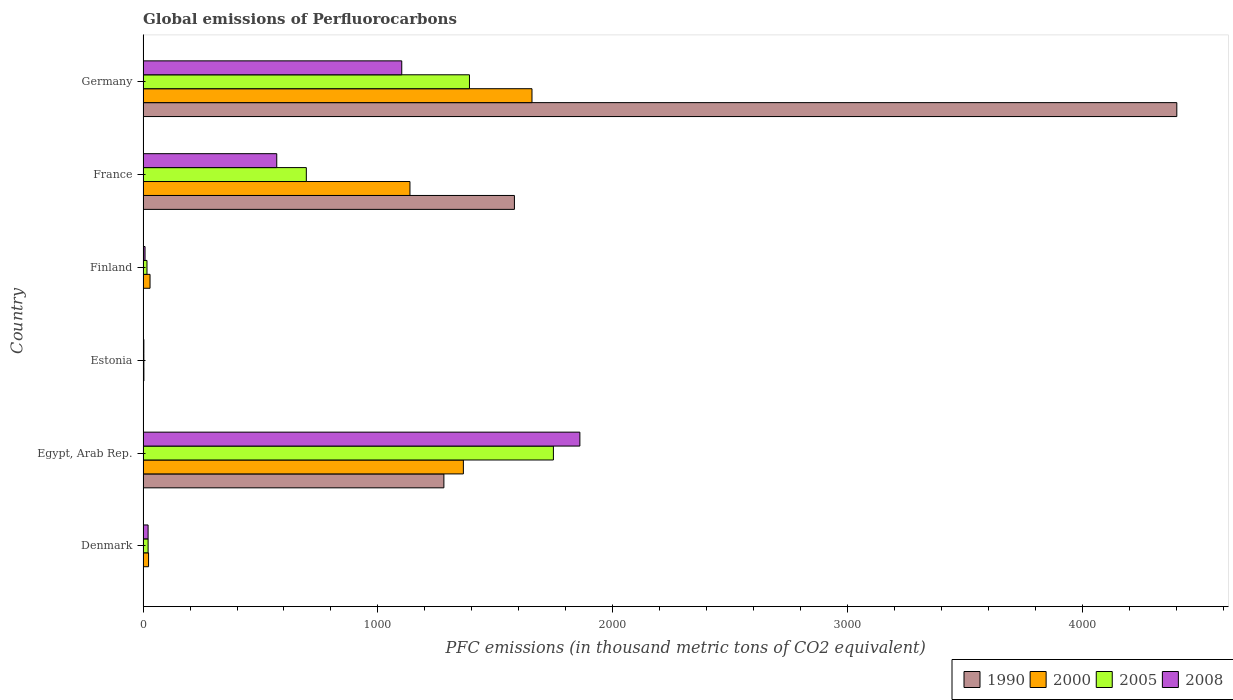Are the number of bars per tick equal to the number of legend labels?
Offer a very short reply. Yes. Are the number of bars on each tick of the Y-axis equal?
Offer a very short reply. Yes. How many bars are there on the 5th tick from the top?
Provide a short and direct response. 4. What is the label of the 4th group of bars from the top?
Your answer should be compact. Estonia. What is the global emissions of Perfluorocarbons in 2000 in Denmark?
Your answer should be compact. 23.4. Across all countries, what is the maximum global emissions of Perfluorocarbons in 1990?
Keep it short and to the point. 4401.3. In which country was the global emissions of Perfluorocarbons in 2000 maximum?
Your answer should be compact. Germany. In which country was the global emissions of Perfluorocarbons in 2008 minimum?
Keep it short and to the point. Estonia. What is the total global emissions of Perfluorocarbons in 2005 in the graph?
Your answer should be compact. 3873.5. What is the difference between the global emissions of Perfluorocarbons in 2005 in Finland and that in Germany?
Provide a succinct answer. -1373. What is the difference between the global emissions of Perfluorocarbons in 2000 in Egypt, Arab Rep. and the global emissions of Perfluorocarbons in 2005 in Germany?
Your response must be concise. -25.9. What is the average global emissions of Perfluorocarbons in 2008 per country?
Ensure brevity in your answer.  593.93. What is the difference between the global emissions of Perfluorocarbons in 2008 and global emissions of Perfluorocarbons in 2005 in Egypt, Arab Rep.?
Your answer should be compact. 112.7. In how many countries, is the global emissions of Perfluorocarbons in 1990 greater than 1000 thousand metric tons?
Make the answer very short. 3. What is the difference between the highest and the second highest global emissions of Perfluorocarbons in 2005?
Give a very brief answer. 357.4. What is the difference between the highest and the lowest global emissions of Perfluorocarbons in 2008?
Give a very brief answer. 1856.4. In how many countries, is the global emissions of Perfluorocarbons in 2008 greater than the average global emissions of Perfluorocarbons in 2008 taken over all countries?
Offer a terse response. 2. Is the sum of the global emissions of Perfluorocarbons in 2008 in Finland and France greater than the maximum global emissions of Perfluorocarbons in 1990 across all countries?
Provide a short and direct response. No. Is it the case that in every country, the sum of the global emissions of Perfluorocarbons in 2008 and global emissions of Perfluorocarbons in 2005 is greater than the sum of global emissions of Perfluorocarbons in 2000 and global emissions of Perfluorocarbons in 1990?
Your answer should be very brief. No. Is it the case that in every country, the sum of the global emissions of Perfluorocarbons in 2008 and global emissions of Perfluorocarbons in 2005 is greater than the global emissions of Perfluorocarbons in 2000?
Your response must be concise. No. Are all the bars in the graph horizontal?
Ensure brevity in your answer.  Yes. How many legend labels are there?
Offer a terse response. 4. How are the legend labels stacked?
Ensure brevity in your answer.  Horizontal. What is the title of the graph?
Your answer should be very brief. Global emissions of Perfluorocarbons. Does "2003" appear as one of the legend labels in the graph?
Make the answer very short. No. What is the label or title of the X-axis?
Your answer should be very brief. PFC emissions (in thousand metric tons of CO2 equivalent). What is the label or title of the Y-axis?
Offer a very short reply. Country. What is the PFC emissions (in thousand metric tons of CO2 equivalent) of 1990 in Denmark?
Your answer should be very brief. 1.4. What is the PFC emissions (in thousand metric tons of CO2 equivalent) in 2000 in Denmark?
Your answer should be very brief. 23.4. What is the PFC emissions (in thousand metric tons of CO2 equivalent) in 2008 in Denmark?
Your answer should be compact. 21.4. What is the PFC emissions (in thousand metric tons of CO2 equivalent) in 1990 in Egypt, Arab Rep.?
Ensure brevity in your answer.  1280.8. What is the PFC emissions (in thousand metric tons of CO2 equivalent) of 2000 in Egypt, Arab Rep.?
Provide a succinct answer. 1363.8. What is the PFC emissions (in thousand metric tons of CO2 equivalent) in 2005 in Egypt, Arab Rep.?
Make the answer very short. 1747.1. What is the PFC emissions (in thousand metric tons of CO2 equivalent) in 2008 in Egypt, Arab Rep.?
Offer a terse response. 1859.8. What is the PFC emissions (in thousand metric tons of CO2 equivalent) of 2000 in Estonia?
Keep it short and to the point. 3.5. What is the PFC emissions (in thousand metric tons of CO2 equivalent) of 2005 in Estonia?
Your response must be concise. 3.4. What is the PFC emissions (in thousand metric tons of CO2 equivalent) of 2008 in Estonia?
Ensure brevity in your answer.  3.4. What is the PFC emissions (in thousand metric tons of CO2 equivalent) of 1990 in Finland?
Your response must be concise. 1.7. What is the PFC emissions (in thousand metric tons of CO2 equivalent) of 2000 in Finland?
Your answer should be compact. 29.7. What is the PFC emissions (in thousand metric tons of CO2 equivalent) in 2008 in Finland?
Ensure brevity in your answer.  8.4. What is the PFC emissions (in thousand metric tons of CO2 equivalent) of 1990 in France?
Provide a short and direct response. 1581.1. What is the PFC emissions (in thousand metric tons of CO2 equivalent) of 2000 in France?
Give a very brief answer. 1136.3. What is the PFC emissions (in thousand metric tons of CO2 equivalent) of 2005 in France?
Offer a terse response. 695.1. What is the PFC emissions (in thousand metric tons of CO2 equivalent) in 2008 in France?
Keep it short and to the point. 569.2. What is the PFC emissions (in thousand metric tons of CO2 equivalent) in 1990 in Germany?
Keep it short and to the point. 4401.3. What is the PFC emissions (in thousand metric tons of CO2 equivalent) of 2000 in Germany?
Give a very brief answer. 1655.9. What is the PFC emissions (in thousand metric tons of CO2 equivalent) of 2005 in Germany?
Give a very brief answer. 1389.7. What is the PFC emissions (in thousand metric tons of CO2 equivalent) in 2008 in Germany?
Keep it short and to the point. 1101.4. Across all countries, what is the maximum PFC emissions (in thousand metric tons of CO2 equivalent) of 1990?
Keep it short and to the point. 4401.3. Across all countries, what is the maximum PFC emissions (in thousand metric tons of CO2 equivalent) of 2000?
Offer a terse response. 1655.9. Across all countries, what is the maximum PFC emissions (in thousand metric tons of CO2 equivalent) of 2005?
Your answer should be very brief. 1747.1. Across all countries, what is the maximum PFC emissions (in thousand metric tons of CO2 equivalent) in 2008?
Make the answer very short. 1859.8. Across all countries, what is the minimum PFC emissions (in thousand metric tons of CO2 equivalent) of 1990?
Your answer should be compact. 0.5. Across all countries, what is the minimum PFC emissions (in thousand metric tons of CO2 equivalent) of 2000?
Keep it short and to the point. 3.5. Across all countries, what is the minimum PFC emissions (in thousand metric tons of CO2 equivalent) of 2005?
Your response must be concise. 3.4. Across all countries, what is the minimum PFC emissions (in thousand metric tons of CO2 equivalent) in 2008?
Offer a very short reply. 3.4. What is the total PFC emissions (in thousand metric tons of CO2 equivalent) of 1990 in the graph?
Make the answer very short. 7266.8. What is the total PFC emissions (in thousand metric tons of CO2 equivalent) in 2000 in the graph?
Ensure brevity in your answer.  4212.6. What is the total PFC emissions (in thousand metric tons of CO2 equivalent) of 2005 in the graph?
Offer a terse response. 3873.5. What is the total PFC emissions (in thousand metric tons of CO2 equivalent) of 2008 in the graph?
Offer a terse response. 3563.6. What is the difference between the PFC emissions (in thousand metric tons of CO2 equivalent) of 1990 in Denmark and that in Egypt, Arab Rep.?
Give a very brief answer. -1279.4. What is the difference between the PFC emissions (in thousand metric tons of CO2 equivalent) of 2000 in Denmark and that in Egypt, Arab Rep.?
Your answer should be compact. -1340.4. What is the difference between the PFC emissions (in thousand metric tons of CO2 equivalent) in 2005 in Denmark and that in Egypt, Arab Rep.?
Give a very brief answer. -1725.6. What is the difference between the PFC emissions (in thousand metric tons of CO2 equivalent) of 2008 in Denmark and that in Egypt, Arab Rep.?
Make the answer very short. -1838.4. What is the difference between the PFC emissions (in thousand metric tons of CO2 equivalent) in 1990 in Denmark and that in Estonia?
Keep it short and to the point. 0.9. What is the difference between the PFC emissions (in thousand metric tons of CO2 equivalent) in 2005 in Denmark and that in Estonia?
Offer a very short reply. 18.1. What is the difference between the PFC emissions (in thousand metric tons of CO2 equivalent) in 1990 in Denmark and that in Finland?
Your answer should be very brief. -0.3. What is the difference between the PFC emissions (in thousand metric tons of CO2 equivalent) of 2005 in Denmark and that in Finland?
Ensure brevity in your answer.  4.8. What is the difference between the PFC emissions (in thousand metric tons of CO2 equivalent) of 2008 in Denmark and that in Finland?
Give a very brief answer. 13. What is the difference between the PFC emissions (in thousand metric tons of CO2 equivalent) of 1990 in Denmark and that in France?
Keep it short and to the point. -1579.7. What is the difference between the PFC emissions (in thousand metric tons of CO2 equivalent) of 2000 in Denmark and that in France?
Provide a short and direct response. -1112.9. What is the difference between the PFC emissions (in thousand metric tons of CO2 equivalent) in 2005 in Denmark and that in France?
Your answer should be compact. -673.6. What is the difference between the PFC emissions (in thousand metric tons of CO2 equivalent) in 2008 in Denmark and that in France?
Your answer should be compact. -547.8. What is the difference between the PFC emissions (in thousand metric tons of CO2 equivalent) in 1990 in Denmark and that in Germany?
Ensure brevity in your answer.  -4399.9. What is the difference between the PFC emissions (in thousand metric tons of CO2 equivalent) in 2000 in Denmark and that in Germany?
Make the answer very short. -1632.5. What is the difference between the PFC emissions (in thousand metric tons of CO2 equivalent) of 2005 in Denmark and that in Germany?
Your response must be concise. -1368.2. What is the difference between the PFC emissions (in thousand metric tons of CO2 equivalent) in 2008 in Denmark and that in Germany?
Ensure brevity in your answer.  -1080. What is the difference between the PFC emissions (in thousand metric tons of CO2 equivalent) of 1990 in Egypt, Arab Rep. and that in Estonia?
Your response must be concise. 1280.3. What is the difference between the PFC emissions (in thousand metric tons of CO2 equivalent) in 2000 in Egypt, Arab Rep. and that in Estonia?
Offer a terse response. 1360.3. What is the difference between the PFC emissions (in thousand metric tons of CO2 equivalent) in 2005 in Egypt, Arab Rep. and that in Estonia?
Your answer should be compact. 1743.7. What is the difference between the PFC emissions (in thousand metric tons of CO2 equivalent) of 2008 in Egypt, Arab Rep. and that in Estonia?
Provide a succinct answer. 1856.4. What is the difference between the PFC emissions (in thousand metric tons of CO2 equivalent) of 1990 in Egypt, Arab Rep. and that in Finland?
Make the answer very short. 1279.1. What is the difference between the PFC emissions (in thousand metric tons of CO2 equivalent) of 2000 in Egypt, Arab Rep. and that in Finland?
Give a very brief answer. 1334.1. What is the difference between the PFC emissions (in thousand metric tons of CO2 equivalent) of 2005 in Egypt, Arab Rep. and that in Finland?
Your answer should be very brief. 1730.4. What is the difference between the PFC emissions (in thousand metric tons of CO2 equivalent) in 2008 in Egypt, Arab Rep. and that in Finland?
Make the answer very short. 1851.4. What is the difference between the PFC emissions (in thousand metric tons of CO2 equivalent) in 1990 in Egypt, Arab Rep. and that in France?
Give a very brief answer. -300.3. What is the difference between the PFC emissions (in thousand metric tons of CO2 equivalent) of 2000 in Egypt, Arab Rep. and that in France?
Provide a succinct answer. 227.5. What is the difference between the PFC emissions (in thousand metric tons of CO2 equivalent) in 2005 in Egypt, Arab Rep. and that in France?
Your answer should be compact. 1052. What is the difference between the PFC emissions (in thousand metric tons of CO2 equivalent) in 2008 in Egypt, Arab Rep. and that in France?
Keep it short and to the point. 1290.6. What is the difference between the PFC emissions (in thousand metric tons of CO2 equivalent) in 1990 in Egypt, Arab Rep. and that in Germany?
Offer a terse response. -3120.5. What is the difference between the PFC emissions (in thousand metric tons of CO2 equivalent) of 2000 in Egypt, Arab Rep. and that in Germany?
Ensure brevity in your answer.  -292.1. What is the difference between the PFC emissions (in thousand metric tons of CO2 equivalent) of 2005 in Egypt, Arab Rep. and that in Germany?
Provide a succinct answer. 357.4. What is the difference between the PFC emissions (in thousand metric tons of CO2 equivalent) of 2008 in Egypt, Arab Rep. and that in Germany?
Your response must be concise. 758.4. What is the difference between the PFC emissions (in thousand metric tons of CO2 equivalent) of 2000 in Estonia and that in Finland?
Ensure brevity in your answer.  -26.2. What is the difference between the PFC emissions (in thousand metric tons of CO2 equivalent) in 2005 in Estonia and that in Finland?
Give a very brief answer. -13.3. What is the difference between the PFC emissions (in thousand metric tons of CO2 equivalent) of 2008 in Estonia and that in Finland?
Offer a terse response. -5. What is the difference between the PFC emissions (in thousand metric tons of CO2 equivalent) in 1990 in Estonia and that in France?
Give a very brief answer. -1580.6. What is the difference between the PFC emissions (in thousand metric tons of CO2 equivalent) in 2000 in Estonia and that in France?
Keep it short and to the point. -1132.8. What is the difference between the PFC emissions (in thousand metric tons of CO2 equivalent) in 2005 in Estonia and that in France?
Make the answer very short. -691.7. What is the difference between the PFC emissions (in thousand metric tons of CO2 equivalent) in 2008 in Estonia and that in France?
Your answer should be very brief. -565.8. What is the difference between the PFC emissions (in thousand metric tons of CO2 equivalent) of 1990 in Estonia and that in Germany?
Your answer should be very brief. -4400.8. What is the difference between the PFC emissions (in thousand metric tons of CO2 equivalent) of 2000 in Estonia and that in Germany?
Give a very brief answer. -1652.4. What is the difference between the PFC emissions (in thousand metric tons of CO2 equivalent) of 2005 in Estonia and that in Germany?
Offer a very short reply. -1386.3. What is the difference between the PFC emissions (in thousand metric tons of CO2 equivalent) in 2008 in Estonia and that in Germany?
Provide a short and direct response. -1098. What is the difference between the PFC emissions (in thousand metric tons of CO2 equivalent) of 1990 in Finland and that in France?
Provide a succinct answer. -1579.4. What is the difference between the PFC emissions (in thousand metric tons of CO2 equivalent) in 2000 in Finland and that in France?
Keep it short and to the point. -1106.6. What is the difference between the PFC emissions (in thousand metric tons of CO2 equivalent) of 2005 in Finland and that in France?
Keep it short and to the point. -678.4. What is the difference between the PFC emissions (in thousand metric tons of CO2 equivalent) of 2008 in Finland and that in France?
Keep it short and to the point. -560.8. What is the difference between the PFC emissions (in thousand metric tons of CO2 equivalent) in 1990 in Finland and that in Germany?
Offer a terse response. -4399.6. What is the difference between the PFC emissions (in thousand metric tons of CO2 equivalent) of 2000 in Finland and that in Germany?
Give a very brief answer. -1626.2. What is the difference between the PFC emissions (in thousand metric tons of CO2 equivalent) of 2005 in Finland and that in Germany?
Keep it short and to the point. -1373. What is the difference between the PFC emissions (in thousand metric tons of CO2 equivalent) of 2008 in Finland and that in Germany?
Keep it short and to the point. -1093. What is the difference between the PFC emissions (in thousand metric tons of CO2 equivalent) in 1990 in France and that in Germany?
Your answer should be very brief. -2820.2. What is the difference between the PFC emissions (in thousand metric tons of CO2 equivalent) of 2000 in France and that in Germany?
Your answer should be compact. -519.6. What is the difference between the PFC emissions (in thousand metric tons of CO2 equivalent) in 2005 in France and that in Germany?
Provide a succinct answer. -694.6. What is the difference between the PFC emissions (in thousand metric tons of CO2 equivalent) in 2008 in France and that in Germany?
Offer a terse response. -532.2. What is the difference between the PFC emissions (in thousand metric tons of CO2 equivalent) of 1990 in Denmark and the PFC emissions (in thousand metric tons of CO2 equivalent) of 2000 in Egypt, Arab Rep.?
Offer a terse response. -1362.4. What is the difference between the PFC emissions (in thousand metric tons of CO2 equivalent) in 1990 in Denmark and the PFC emissions (in thousand metric tons of CO2 equivalent) in 2005 in Egypt, Arab Rep.?
Make the answer very short. -1745.7. What is the difference between the PFC emissions (in thousand metric tons of CO2 equivalent) in 1990 in Denmark and the PFC emissions (in thousand metric tons of CO2 equivalent) in 2008 in Egypt, Arab Rep.?
Make the answer very short. -1858.4. What is the difference between the PFC emissions (in thousand metric tons of CO2 equivalent) of 2000 in Denmark and the PFC emissions (in thousand metric tons of CO2 equivalent) of 2005 in Egypt, Arab Rep.?
Ensure brevity in your answer.  -1723.7. What is the difference between the PFC emissions (in thousand metric tons of CO2 equivalent) in 2000 in Denmark and the PFC emissions (in thousand metric tons of CO2 equivalent) in 2008 in Egypt, Arab Rep.?
Provide a short and direct response. -1836.4. What is the difference between the PFC emissions (in thousand metric tons of CO2 equivalent) in 2005 in Denmark and the PFC emissions (in thousand metric tons of CO2 equivalent) in 2008 in Egypt, Arab Rep.?
Your answer should be compact. -1838.3. What is the difference between the PFC emissions (in thousand metric tons of CO2 equivalent) in 2000 in Denmark and the PFC emissions (in thousand metric tons of CO2 equivalent) in 2005 in Estonia?
Offer a terse response. 20. What is the difference between the PFC emissions (in thousand metric tons of CO2 equivalent) in 1990 in Denmark and the PFC emissions (in thousand metric tons of CO2 equivalent) in 2000 in Finland?
Offer a terse response. -28.3. What is the difference between the PFC emissions (in thousand metric tons of CO2 equivalent) of 1990 in Denmark and the PFC emissions (in thousand metric tons of CO2 equivalent) of 2005 in Finland?
Provide a succinct answer. -15.3. What is the difference between the PFC emissions (in thousand metric tons of CO2 equivalent) in 2000 in Denmark and the PFC emissions (in thousand metric tons of CO2 equivalent) in 2005 in Finland?
Ensure brevity in your answer.  6.7. What is the difference between the PFC emissions (in thousand metric tons of CO2 equivalent) of 1990 in Denmark and the PFC emissions (in thousand metric tons of CO2 equivalent) of 2000 in France?
Provide a succinct answer. -1134.9. What is the difference between the PFC emissions (in thousand metric tons of CO2 equivalent) of 1990 in Denmark and the PFC emissions (in thousand metric tons of CO2 equivalent) of 2005 in France?
Your answer should be compact. -693.7. What is the difference between the PFC emissions (in thousand metric tons of CO2 equivalent) of 1990 in Denmark and the PFC emissions (in thousand metric tons of CO2 equivalent) of 2008 in France?
Your answer should be very brief. -567.8. What is the difference between the PFC emissions (in thousand metric tons of CO2 equivalent) in 2000 in Denmark and the PFC emissions (in thousand metric tons of CO2 equivalent) in 2005 in France?
Keep it short and to the point. -671.7. What is the difference between the PFC emissions (in thousand metric tons of CO2 equivalent) in 2000 in Denmark and the PFC emissions (in thousand metric tons of CO2 equivalent) in 2008 in France?
Keep it short and to the point. -545.8. What is the difference between the PFC emissions (in thousand metric tons of CO2 equivalent) in 2005 in Denmark and the PFC emissions (in thousand metric tons of CO2 equivalent) in 2008 in France?
Your response must be concise. -547.7. What is the difference between the PFC emissions (in thousand metric tons of CO2 equivalent) of 1990 in Denmark and the PFC emissions (in thousand metric tons of CO2 equivalent) of 2000 in Germany?
Your response must be concise. -1654.5. What is the difference between the PFC emissions (in thousand metric tons of CO2 equivalent) of 1990 in Denmark and the PFC emissions (in thousand metric tons of CO2 equivalent) of 2005 in Germany?
Keep it short and to the point. -1388.3. What is the difference between the PFC emissions (in thousand metric tons of CO2 equivalent) of 1990 in Denmark and the PFC emissions (in thousand metric tons of CO2 equivalent) of 2008 in Germany?
Ensure brevity in your answer.  -1100. What is the difference between the PFC emissions (in thousand metric tons of CO2 equivalent) in 2000 in Denmark and the PFC emissions (in thousand metric tons of CO2 equivalent) in 2005 in Germany?
Offer a very short reply. -1366.3. What is the difference between the PFC emissions (in thousand metric tons of CO2 equivalent) of 2000 in Denmark and the PFC emissions (in thousand metric tons of CO2 equivalent) of 2008 in Germany?
Provide a succinct answer. -1078. What is the difference between the PFC emissions (in thousand metric tons of CO2 equivalent) in 2005 in Denmark and the PFC emissions (in thousand metric tons of CO2 equivalent) in 2008 in Germany?
Your response must be concise. -1079.9. What is the difference between the PFC emissions (in thousand metric tons of CO2 equivalent) in 1990 in Egypt, Arab Rep. and the PFC emissions (in thousand metric tons of CO2 equivalent) in 2000 in Estonia?
Your response must be concise. 1277.3. What is the difference between the PFC emissions (in thousand metric tons of CO2 equivalent) of 1990 in Egypt, Arab Rep. and the PFC emissions (in thousand metric tons of CO2 equivalent) of 2005 in Estonia?
Make the answer very short. 1277.4. What is the difference between the PFC emissions (in thousand metric tons of CO2 equivalent) of 1990 in Egypt, Arab Rep. and the PFC emissions (in thousand metric tons of CO2 equivalent) of 2008 in Estonia?
Make the answer very short. 1277.4. What is the difference between the PFC emissions (in thousand metric tons of CO2 equivalent) in 2000 in Egypt, Arab Rep. and the PFC emissions (in thousand metric tons of CO2 equivalent) in 2005 in Estonia?
Your response must be concise. 1360.4. What is the difference between the PFC emissions (in thousand metric tons of CO2 equivalent) of 2000 in Egypt, Arab Rep. and the PFC emissions (in thousand metric tons of CO2 equivalent) of 2008 in Estonia?
Your answer should be very brief. 1360.4. What is the difference between the PFC emissions (in thousand metric tons of CO2 equivalent) of 2005 in Egypt, Arab Rep. and the PFC emissions (in thousand metric tons of CO2 equivalent) of 2008 in Estonia?
Keep it short and to the point. 1743.7. What is the difference between the PFC emissions (in thousand metric tons of CO2 equivalent) of 1990 in Egypt, Arab Rep. and the PFC emissions (in thousand metric tons of CO2 equivalent) of 2000 in Finland?
Provide a succinct answer. 1251.1. What is the difference between the PFC emissions (in thousand metric tons of CO2 equivalent) in 1990 in Egypt, Arab Rep. and the PFC emissions (in thousand metric tons of CO2 equivalent) in 2005 in Finland?
Your answer should be very brief. 1264.1. What is the difference between the PFC emissions (in thousand metric tons of CO2 equivalent) in 1990 in Egypt, Arab Rep. and the PFC emissions (in thousand metric tons of CO2 equivalent) in 2008 in Finland?
Give a very brief answer. 1272.4. What is the difference between the PFC emissions (in thousand metric tons of CO2 equivalent) of 2000 in Egypt, Arab Rep. and the PFC emissions (in thousand metric tons of CO2 equivalent) of 2005 in Finland?
Provide a short and direct response. 1347.1. What is the difference between the PFC emissions (in thousand metric tons of CO2 equivalent) in 2000 in Egypt, Arab Rep. and the PFC emissions (in thousand metric tons of CO2 equivalent) in 2008 in Finland?
Ensure brevity in your answer.  1355.4. What is the difference between the PFC emissions (in thousand metric tons of CO2 equivalent) of 2005 in Egypt, Arab Rep. and the PFC emissions (in thousand metric tons of CO2 equivalent) of 2008 in Finland?
Provide a succinct answer. 1738.7. What is the difference between the PFC emissions (in thousand metric tons of CO2 equivalent) in 1990 in Egypt, Arab Rep. and the PFC emissions (in thousand metric tons of CO2 equivalent) in 2000 in France?
Ensure brevity in your answer.  144.5. What is the difference between the PFC emissions (in thousand metric tons of CO2 equivalent) in 1990 in Egypt, Arab Rep. and the PFC emissions (in thousand metric tons of CO2 equivalent) in 2005 in France?
Make the answer very short. 585.7. What is the difference between the PFC emissions (in thousand metric tons of CO2 equivalent) of 1990 in Egypt, Arab Rep. and the PFC emissions (in thousand metric tons of CO2 equivalent) of 2008 in France?
Make the answer very short. 711.6. What is the difference between the PFC emissions (in thousand metric tons of CO2 equivalent) in 2000 in Egypt, Arab Rep. and the PFC emissions (in thousand metric tons of CO2 equivalent) in 2005 in France?
Your answer should be very brief. 668.7. What is the difference between the PFC emissions (in thousand metric tons of CO2 equivalent) of 2000 in Egypt, Arab Rep. and the PFC emissions (in thousand metric tons of CO2 equivalent) of 2008 in France?
Offer a terse response. 794.6. What is the difference between the PFC emissions (in thousand metric tons of CO2 equivalent) of 2005 in Egypt, Arab Rep. and the PFC emissions (in thousand metric tons of CO2 equivalent) of 2008 in France?
Give a very brief answer. 1177.9. What is the difference between the PFC emissions (in thousand metric tons of CO2 equivalent) in 1990 in Egypt, Arab Rep. and the PFC emissions (in thousand metric tons of CO2 equivalent) in 2000 in Germany?
Your answer should be compact. -375.1. What is the difference between the PFC emissions (in thousand metric tons of CO2 equivalent) of 1990 in Egypt, Arab Rep. and the PFC emissions (in thousand metric tons of CO2 equivalent) of 2005 in Germany?
Your answer should be very brief. -108.9. What is the difference between the PFC emissions (in thousand metric tons of CO2 equivalent) of 1990 in Egypt, Arab Rep. and the PFC emissions (in thousand metric tons of CO2 equivalent) of 2008 in Germany?
Your answer should be compact. 179.4. What is the difference between the PFC emissions (in thousand metric tons of CO2 equivalent) of 2000 in Egypt, Arab Rep. and the PFC emissions (in thousand metric tons of CO2 equivalent) of 2005 in Germany?
Your response must be concise. -25.9. What is the difference between the PFC emissions (in thousand metric tons of CO2 equivalent) of 2000 in Egypt, Arab Rep. and the PFC emissions (in thousand metric tons of CO2 equivalent) of 2008 in Germany?
Your answer should be very brief. 262.4. What is the difference between the PFC emissions (in thousand metric tons of CO2 equivalent) of 2005 in Egypt, Arab Rep. and the PFC emissions (in thousand metric tons of CO2 equivalent) of 2008 in Germany?
Keep it short and to the point. 645.7. What is the difference between the PFC emissions (in thousand metric tons of CO2 equivalent) of 1990 in Estonia and the PFC emissions (in thousand metric tons of CO2 equivalent) of 2000 in Finland?
Your answer should be compact. -29.2. What is the difference between the PFC emissions (in thousand metric tons of CO2 equivalent) of 1990 in Estonia and the PFC emissions (in thousand metric tons of CO2 equivalent) of 2005 in Finland?
Make the answer very short. -16.2. What is the difference between the PFC emissions (in thousand metric tons of CO2 equivalent) of 1990 in Estonia and the PFC emissions (in thousand metric tons of CO2 equivalent) of 2000 in France?
Make the answer very short. -1135.8. What is the difference between the PFC emissions (in thousand metric tons of CO2 equivalent) of 1990 in Estonia and the PFC emissions (in thousand metric tons of CO2 equivalent) of 2005 in France?
Give a very brief answer. -694.6. What is the difference between the PFC emissions (in thousand metric tons of CO2 equivalent) in 1990 in Estonia and the PFC emissions (in thousand metric tons of CO2 equivalent) in 2008 in France?
Your response must be concise. -568.7. What is the difference between the PFC emissions (in thousand metric tons of CO2 equivalent) in 2000 in Estonia and the PFC emissions (in thousand metric tons of CO2 equivalent) in 2005 in France?
Your response must be concise. -691.6. What is the difference between the PFC emissions (in thousand metric tons of CO2 equivalent) in 2000 in Estonia and the PFC emissions (in thousand metric tons of CO2 equivalent) in 2008 in France?
Keep it short and to the point. -565.7. What is the difference between the PFC emissions (in thousand metric tons of CO2 equivalent) of 2005 in Estonia and the PFC emissions (in thousand metric tons of CO2 equivalent) of 2008 in France?
Your answer should be compact. -565.8. What is the difference between the PFC emissions (in thousand metric tons of CO2 equivalent) in 1990 in Estonia and the PFC emissions (in thousand metric tons of CO2 equivalent) in 2000 in Germany?
Your answer should be very brief. -1655.4. What is the difference between the PFC emissions (in thousand metric tons of CO2 equivalent) of 1990 in Estonia and the PFC emissions (in thousand metric tons of CO2 equivalent) of 2005 in Germany?
Provide a succinct answer. -1389.2. What is the difference between the PFC emissions (in thousand metric tons of CO2 equivalent) in 1990 in Estonia and the PFC emissions (in thousand metric tons of CO2 equivalent) in 2008 in Germany?
Ensure brevity in your answer.  -1100.9. What is the difference between the PFC emissions (in thousand metric tons of CO2 equivalent) in 2000 in Estonia and the PFC emissions (in thousand metric tons of CO2 equivalent) in 2005 in Germany?
Ensure brevity in your answer.  -1386.2. What is the difference between the PFC emissions (in thousand metric tons of CO2 equivalent) of 2000 in Estonia and the PFC emissions (in thousand metric tons of CO2 equivalent) of 2008 in Germany?
Offer a very short reply. -1097.9. What is the difference between the PFC emissions (in thousand metric tons of CO2 equivalent) of 2005 in Estonia and the PFC emissions (in thousand metric tons of CO2 equivalent) of 2008 in Germany?
Keep it short and to the point. -1098. What is the difference between the PFC emissions (in thousand metric tons of CO2 equivalent) of 1990 in Finland and the PFC emissions (in thousand metric tons of CO2 equivalent) of 2000 in France?
Your response must be concise. -1134.6. What is the difference between the PFC emissions (in thousand metric tons of CO2 equivalent) of 1990 in Finland and the PFC emissions (in thousand metric tons of CO2 equivalent) of 2005 in France?
Offer a terse response. -693.4. What is the difference between the PFC emissions (in thousand metric tons of CO2 equivalent) in 1990 in Finland and the PFC emissions (in thousand metric tons of CO2 equivalent) in 2008 in France?
Your answer should be compact. -567.5. What is the difference between the PFC emissions (in thousand metric tons of CO2 equivalent) in 2000 in Finland and the PFC emissions (in thousand metric tons of CO2 equivalent) in 2005 in France?
Provide a short and direct response. -665.4. What is the difference between the PFC emissions (in thousand metric tons of CO2 equivalent) in 2000 in Finland and the PFC emissions (in thousand metric tons of CO2 equivalent) in 2008 in France?
Provide a succinct answer. -539.5. What is the difference between the PFC emissions (in thousand metric tons of CO2 equivalent) of 2005 in Finland and the PFC emissions (in thousand metric tons of CO2 equivalent) of 2008 in France?
Your response must be concise. -552.5. What is the difference between the PFC emissions (in thousand metric tons of CO2 equivalent) of 1990 in Finland and the PFC emissions (in thousand metric tons of CO2 equivalent) of 2000 in Germany?
Make the answer very short. -1654.2. What is the difference between the PFC emissions (in thousand metric tons of CO2 equivalent) of 1990 in Finland and the PFC emissions (in thousand metric tons of CO2 equivalent) of 2005 in Germany?
Keep it short and to the point. -1388. What is the difference between the PFC emissions (in thousand metric tons of CO2 equivalent) in 1990 in Finland and the PFC emissions (in thousand metric tons of CO2 equivalent) in 2008 in Germany?
Provide a succinct answer. -1099.7. What is the difference between the PFC emissions (in thousand metric tons of CO2 equivalent) in 2000 in Finland and the PFC emissions (in thousand metric tons of CO2 equivalent) in 2005 in Germany?
Ensure brevity in your answer.  -1360. What is the difference between the PFC emissions (in thousand metric tons of CO2 equivalent) of 2000 in Finland and the PFC emissions (in thousand metric tons of CO2 equivalent) of 2008 in Germany?
Make the answer very short. -1071.7. What is the difference between the PFC emissions (in thousand metric tons of CO2 equivalent) in 2005 in Finland and the PFC emissions (in thousand metric tons of CO2 equivalent) in 2008 in Germany?
Give a very brief answer. -1084.7. What is the difference between the PFC emissions (in thousand metric tons of CO2 equivalent) of 1990 in France and the PFC emissions (in thousand metric tons of CO2 equivalent) of 2000 in Germany?
Your answer should be compact. -74.8. What is the difference between the PFC emissions (in thousand metric tons of CO2 equivalent) of 1990 in France and the PFC emissions (in thousand metric tons of CO2 equivalent) of 2005 in Germany?
Offer a very short reply. 191.4. What is the difference between the PFC emissions (in thousand metric tons of CO2 equivalent) in 1990 in France and the PFC emissions (in thousand metric tons of CO2 equivalent) in 2008 in Germany?
Ensure brevity in your answer.  479.7. What is the difference between the PFC emissions (in thousand metric tons of CO2 equivalent) of 2000 in France and the PFC emissions (in thousand metric tons of CO2 equivalent) of 2005 in Germany?
Your answer should be compact. -253.4. What is the difference between the PFC emissions (in thousand metric tons of CO2 equivalent) in 2000 in France and the PFC emissions (in thousand metric tons of CO2 equivalent) in 2008 in Germany?
Your response must be concise. 34.9. What is the difference between the PFC emissions (in thousand metric tons of CO2 equivalent) in 2005 in France and the PFC emissions (in thousand metric tons of CO2 equivalent) in 2008 in Germany?
Your response must be concise. -406.3. What is the average PFC emissions (in thousand metric tons of CO2 equivalent) of 1990 per country?
Make the answer very short. 1211.13. What is the average PFC emissions (in thousand metric tons of CO2 equivalent) in 2000 per country?
Ensure brevity in your answer.  702.1. What is the average PFC emissions (in thousand metric tons of CO2 equivalent) in 2005 per country?
Offer a very short reply. 645.58. What is the average PFC emissions (in thousand metric tons of CO2 equivalent) of 2008 per country?
Provide a succinct answer. 593.93. What is the difference between the PFC emissions (in thousand metric tons of CO2 equivalent) in 1990 and PFC emissions (in thousand metric tons of CO2 equivalent) in 2000 in Denmark?
Offer a very short reply. -22. What is the difference between the PFC emissions (in thousand metric tons of CO2 equivalent) of 1990 and PFC emissions (in thousand metric tons of CO2 equivalent) of 2005 in Denmark?
Your answer should be compact. -20.1. What is the difference between the PFC emissions (in thousand metric tons of CO2 equivalent) of 2000 and PFC emissions (in thousand metric tons of CO2 equivalent) of 2005 in Denmark?
Make the answer very short. 1.9. What is the difference between the PFC emissions (in thousand metric tons of CO2 equivalent) in 2000 and PFC emissions (in thousand metric tons of CO2 equivalent) in 2008 in Denmark?
Keep it short and to the point. 2. What is the difference between the PFC emissions (in thousand metric tons of CO2 equivalent) of 2005 and PFC emissions (in thousand metric tons of CO2 equivalent) of 2008 in Denmark?
Keep it short and to the point. 0.1. What is the difference between the PFC emissions (in thousand metric tons of CO2 equivalent) in 1990 and PFC emissions (in thousand metric tons of CO2 equivalent) in 2000 in Egypt, Arab Rep.?
Your answer should be compact. -83. What is the difference between the PFC emissions (in thousand metric tons of CO2 equivalent) in 1990 and PFC emissions (in thousand metric tons of CO2 equivalent) in 2005 in Egypt, Arab Rep.?
Provide a short and direct response. -466.3. What is the difference between the PFC emissions (in thousand metric tons of CO2 equivalent) in 1990 and PFC emissions (in thousand metric tons of CO2 equivalent) in 2008 in Egypt, Arab Rep.?
Make the answer very short. -579. What is the difference between the PFC emissions (in thousand metric tons of CO2 equivalent) of 2000 and PFC emissions (in thousand metric tons of CO2 equivalent) of 2005 in Egypt, Arab Rep.?
Your answer should be compact. -383.3. What is the difference between the PFC emissions (in thousand metric tons of CO2 equivalent) in 2000 and PFC emissions (in thousand metric tons of CO2 equivalent) in 2008 in Egypt, Arab Rep.?
Give a very brief answer. -496. What is the difference between the PFC emissions (in thousand metric tons of CO2 equivalent) in 2005 and PFC emissions (in thousand metric tons of CO2 equivalent) in 2008 in Egypt, Arab Rep.?
Your response must be concise. -112.7. What is the difference between the PFC emissions (in thousand metric tons of CO2 equivalent) in 1990 and PFC emissions (in thousand metric tons of CO2 equivalent) in 2000 in Estonia?
Provide a short and direct response. -3. What is the difference between the PFC emissions (in thousand metric tons of CO2 equivalent) in 1990 and PFC emissions (in thousand metric tons of CO2 equivalent) in 2005 in Estonia?
Make the answer very short. -2.9. What is the difference between the PFC emissions (in thousand metric tons of CO2 equivalent) in 1990 and PFC emissions (in thousand metric tons of CO2 equivalent) in 2008 in Estonia?
Provide a succinct answer. -2.9. What is the difference between the PFC emissions (in thousand metric tons of CO2 equivalent) in 2000 and PFC emissions (in thousand metric tons of CO2 equivalent) in 2005 in Estonia?
Your answer should be compact. 0.1. What is the difference between the PFC emissions (in thousand metric tons of CO2 equivalent) in 2000 and PFC emissions (in thousand metric tons of CO2 equivalent) in 2008 in Estonia?
Make the answer very short. 0.1. What is the difference between the PFC emissions (in thousand metric tons of CO2 equivalent) of 2005 and PFC emissions (in thousand metric tons of CO2 equivalent) of 2008 in Estonia?
Provide a short and direct response. 0. What is the difference between the PFC emissions (in thousand metric tons of CO2 equivalent) in 1990 and PFC emissions (in thousand metric tons of CO2 equivalent) in 2005 in Finland?
Make the answer very short. -15. What is the difference between the PFC emissions (in thousand metric tons of CO2 equivalent) in 1990 and PFC emissions (in thousand metric tons of CO2 equivalent) in 2008 in Finland?
Give a very brief answer. -6.7. What is the difference between the PFC emissions (in thousand metric tons of CO2 equivalent) of 2000 and PFC emissions (in thousand metric tons of CO2 equivalent) of 2008 in Finland?
Make the answer very short. 21.3. What is the difference between the PFC emissions (in thousand metric tons of CO2 equivalent) of 2005 and PFC emissions (in thousand metric tons of CO2 equivalent) of 2008 in Finland?
Your response must be concise. 8.3. What is the difference between the PFC emissions (in thousand metric tons of CO2 equivalent) in 1990 and PFC emissions (in thousand metric tons of CO2 equivalent) in 2000 in France?
Your answer should be compact. 444.8. What is the difference between the PFC emissions (in thousand metric tons of CO2 equivalent) of 1990 and PFC emissions (in thousand metric tons of CO2 equivalent) of 2005 in France?
Your answer should be compact. 886. What is the difference between the PFC emissions (in thousand metric tons of CO2 equivalent) in 1990 and PFC emissions (in thousand metric tons of CO2 equivalent) in 2008 in France?
Offer a terse response. 1011.9. What is the difference between the PFC emissions (in thousand metric tons of CO2 equivalent) of 2000 and PFC emissions (in thousand metric tons of CO2 equivalent) of 2005 in France?
Give a very brief answer. 441.2. What is the difference between the PFC emissions (in thousand metric tons of CO2 equivalent) of 2000 and PFC emissions (in thousand metric tons of CO2 equivalent) of 2008 in France?
Your answer should be very brief. 567.1. What is the difference between the PFC emissions (in thousand metric tons of CO2 equivalent) in 2005 and PFC emissions (in thousand metric tons of CO2 equivalent) in 2008 in France?
Offer a terse response. 125.9. What is the difference between the PFC emissions (in thousand metric tons of CO2 equivalent) of 1990 and PFC emissions (in thousand metric tons of CO2 equivalent) of 2000 in Germany?
Keep it short and to the point. 2745.4. What is the difference between the PFC emissions (in thousand metric tons of CO2 equivalent) of 1990 and PFC emissions (in thousand metric tons of CO2 equivalent) of 2005 in Germany?
Your answer should be compact. 3011.6. What is the difference between the PFC emissions (in thousand metric tons of CO2 equivalent) in 1990 and PFC emissions (in thousand metric tons of CO2 equivalent) in 2008 in Germany?
Give a very brief answer. 3299.9. What is the difference between the PFC emissions (in thousand metric tons of CO2 equivalent) of 2000 and PFC emissions (in thousand metric tons of CO2 equivalent) of 2005 in Germany?
Offer a very short reply. 266.2. What is the difference between the PFC emissions (in thousand metric tons of CO2 equivalent) of 2000 and PFC emissions (in thousand metric tons of CO2 equivalent) of 2008 in Germany?
Offer a terse response. 554.5. What is the difference between the PFC emissions (in thousand metric tons of CO2 equivalent) in 2005 and PFC emissions (in thousand metric tons of CO2 equivalent) in 2008 in Germany?
Make the answer very short. 288.3. What is the ratio of the PFC emissions (in thousand metric tons of CO2 equivalent) in 1990 in Denmark to that in Egypt, Arab Rep.?
Ensure brevity in your answer.  0. What is the ratio of the PFC emissions (in thousand metric tons of CO2 equivalent) of 2000 in Denmark to that in Egypt, Arab Rep.?
Keep it short and to the point. 0.02. What is the ratio of the PFC emissions (in thousand metric tons of CO2 equivalent) in 2005 in Denmark to that in Egypt, Arab Rep.?
Your response must be concise. 0.01. What is the ratio of the PFC emissions (in thousand metric tons of CO2 equivalent) of 2008 in Denmark to that in Egypt, Arab Rep.?
Your response must be concise. 0.01. What is the ratio of the PFC emissions (in thousand metric tons of CO2 equivalent) in 1990 in Denmark to that in Estonia?
Your answer should be compact. 2.8. What is the ratio of the PFC emissions (in thousand metric tons of CO2 equivalent) of 2000 in Denmark to that in Estonia?
Provide a succinct answer. 6.69. What is the ratio of the PFC emissions (in thousand metric tons of CO2 equivalent) in 2005 in Denmark to that in Estonia?
Give a very brief answer. 6.32. What is the ratio of the PFC emissions (in thousand metric tons of CO2 equivalent) of 2008 in Denmark to that in Estonia?
Offer a terse response. 6.29. What is the ratio of the PFC emissions (in thousand metric tons of CO2 equivalent) of 1990 in Denmark to that in Finland?
Make the answer very short. 0.82. What is the ratio of the PFC emissions (in thousand metric tons of CO2 equivalent) of 2000 in Denmark to that in Finland?
Ensure brevity in your answer.  0.79. What is the ratio of the PFC emissions (in thousand metric tons of CO2 equivalent) of 2005 in Denmark to that in Finland?
Your response must be concise. 1.29. What is the ratio of the PFC emissions (in thousand metric tons of CO2 equivalent) in 2008 in Denmark to that in Finland?
Offer a terse response. 2.55. What is the ratio of the PFC emissions (in thousand metric tons of CO2 equivalent) in 1990 in Denmark to that in France?
Make the answer very short. 0. What is the ratio of the PFC emissions (in thousand metric tons of CO2 equivalent) of 2000 in Denmark to that in France?
Provide a succinct answer. 0.02. What is the ratio of the PFC emissions (in thousand metric tons of CO2 equivalent) in 2005 in Denmark to that in France?
Your answer should be very brief. 0.03. What is the ratio of the PFC emissions (in thousand metric tons of CO2 equivalent) of 2008 in Denmark to that in France?
Provide a short and direct response. 0.04. What is the ratio of the PFC emissions (in thousand metric tons of CO2 equivalent) in 2000 in Denmark to that in Germany?
Your answer should be compact. 0.01. What is the ratio of the PFC emissions (in thousand metric tons of CO2 equivalent) of 2005 in Denmark to that in Germany?
Offer a very short reply. 0.02. What is the ratio of the PFC emissions (in thousand metric tons of CO2 equivalent) in 2008 in Denmark to that in Germany?
Offer a very short reply. 0.02. What is the ratio of the PFC emissions (in thousand metric tons of CO2 equivalent) of 1990 in Egypt, Arab Rep. to that in Estonia?
Give a very brief answer. 2561.6. What is the ratio of the PFC emissions (in thousand metric tons of CO2 equivalent) of 2000 in Egypt, Arab Rep. to that in Estonia?
Offer a terse response. 389.66. What is the ratio of the PFC emissions (in thousand metric tons of CO2 equivalent) of 2005 in Egypt, Arab Rep. to that in Estonia?
Provide a succinct answer. 513.85. What is the ratio of the PFC emissions (in thousand metric tons of CO2 equivalent) in 2008 in Egypt, Arab Rep. to that in Estonia?
Ensure brevity in your answer.  547. What is the ratio of the PFC emissions (in thousand metric tons of CO2 equivalent) of 1990 in Egypt, Arab Rep. to that in Finland?
Your answer should be compact. 753.41. What is the ratio of the PFC emissions (in thousand metric tons of CO2 equivalent) of 2000 in Egypt, Arab Rep. to that in Finland?
Give a very brief answer. 45.92. What is the ratio of the PFC emissions (in thousand metric tons of CO2 equivalent) in 2005 in Egypt, Arab Rep. to that in Finland?
Offer a very short reply. 104.62. What is the ratio of the PFC emissions (in thousand metric tons of CO2 equivalent) of 2008 in Egypt, Arab Rep. to that in Finland?
Provide a short and direct response. 221.4. What is the ratio of the PFC emissions (in thousand metric tons of CO2 equivalent) of 1990 in Egypt, Arab Rep. to that in France?
Provide a short and direct response. 0.81. What is the ratio of the PFC emissions (in thousand metric tons of CO2 equivalent) of 2000 in Egypt, Arab Rep. to that in France?
Your answer should be very brief. 1.2. What is the ratio of the PFC emissions (in thousand metric tons of CO2 equivalent) in 2005 in Egypt, Arab Rep. to that in France?
Your response must be concise. 2.51. What is the ratio of the PFC emissions (in thousand metric tons of CO2 equivalent) of 2008 in Egypt, Arab Rep. to that in France?
Your answer should be very brief. 3.27. What is the ratio of the PFC emissions (in thousand metric tons of CO2 equivalent) of 1990 in Egypt, Arab Rep. to that in Germany?
Your answer should be compact. 0.29. What is the ratio of the PFC emissions (in thousand metric tons of CO2 equivalent) of 2000 in Egypt, Arab Rep. to that in Germany?
Make the answer very short. 0.82. What is the ratio of the PFC emissions (in thousand metric tons of CO2 equivalent) in 2005 in Egypt, Arab Rep. to that in Germany?
Make the answer very short. 1.26. What is the ratio of the PFC emissions (in thousand metric tons of CO2 equivalent) of 2008 in Egypt, Arab Rep. to that in Germany?
Provide a succinct answer. 1.69. What is the ratio of the PFC emissions (in thousand metric tons of CO2 equivalent) in 1990 in Estonia to that in Finland?
Give a very brief answer. 0.29. What is the ratio of the PFC emissions (in thousand metric tons of CO2 equivalent) in 2000 in Estonia to that in Finland?
Give a very brief answer. 0.12. What is the ratio of the PFC emissions (in thousand metric tons of CO2 equivalent) in 2005 in Estonia to that in Finland?
Offer a very short reply. 0.2. What is the ratio of the PFC emissions (in thousand metric tons of CO2 equivalent) of 2008 in Estonia to that in Finland?
Your answer should be very brief. 0.4. What is the ratio of the PFC emissions (in thousand metric tons of CO2 equivalent) in 1990 in Estonia to that in France?
Your answer should be very brief. 0. What is the ratio of the PFC emissions (in thousand metric tons of CO2 equivalent) of 2000 in Estonia to that in France?
Your response must be concise. 0. What is the ratio of the PFC emissions (in thousand metric tons of CO2 equivalent) in 2005 in Estonia to that in France?
Keep it short and to the point. 0. What is the ratio of the PFC emissions (in thousand metric tons of CO2 equivalent) of 2008 in Estonia to that in France?
Provide a short and direct response. 0.01. What is the ratio of the PFC emissions (in thousand metric tons of CO2 equivalent) of 1990 in Estonia to that in Germany?
Give a very brief answer. 0. What is the ratio of the PFC emissions (in thousand metric tons of CO2 equivalent) in 2000 in Estonia to that in Germany?
Ensure brevity in your answer.  0. What is the ratio of the PFC emissions (in thousand metric tons of CO2 equivalent) of 2005 in Estonia to that in Germany?
Provide a succinct answer. 0. What is the ratio of the PFC emissions (in thousand metric tons of CO2 equivalent) in 2008 in Estonia to that in Germany?
Provide a short and direct response. 0. What is the ratio of the PFC emissions (in thousand metric tons of CO2 equivalent) in 1990 in Finland to that in France?
Offer a terse response. 0. What is the ratio of the PFC emissions (in thousand metric tons of CO2 equivalent) in 2000 in Finland to that in France?
Your response must be concise. 0.03. What is the ratio of the PFC emissions (in thousand metric tons of CO2 equivalent) of 2005 in Finland to that in France?
Your answer should be compact. 0.02. What is the ratio of the PFC emissions (in thousand metric tons of CO2 equivalent) in 2008 in Finland to that in France?
Offer a terse response. 0.01. What is the ratio of the PFC emissions (in thousand metric tons of CO2 equivalent) of 2000 in Finland to that in Germany?
Ensure brevity in your answer.  0.02. What is the ratio of the PFC emissions (in thousand metric tons of CO2 equivalent) in 2005 in Finland to that in Germany?
Your response must be concise. 0.01. What is the ratio of the PFC emissions (in thousand metric tons of CO2 equivalent) in 2008 in Finland to that in Germany?
Offer a very short reply. 0.01. What is the ratio of the PFC emissions (in thousand metric tons of CO2 equivalent) in 1990 in France to that in Germany?
Provide a succinct answer. 0.36. What is the ratio of the PFC emissions (in thousand metric tons of CO2 equivalent) of 2000 in France to that in Germany?
Offer a very short reply. 0.69. What is the ratio of the PFC emissions (in thousand metric tons of CO2 equivalent) of 2005 in France to that in Germany?
Ensure brevity in your answer.  0.5. What is the ratio of the PFC emissions (in thousand metric tons of CO2 equivalent) in 2008 in France to that in Germany?
Give a very brief answer. 0.52. What is the difference between the highest and the second highest PFC emissions (in thousand metric tons of CO2 equivalent) in 1990?
Ensure brevity in your answer.  2820.2. What is the difference between the highest and the second highest PFC emissions (in thousand metric tons of CO2 equivalent) of 2000?
Offer a terse response. 292.1. What is the difference between the highest and the second highest PFC emissions (in thousand metric tons of CO2 equivalent) in 2005?
Your answer should be compact. 357.4. What is the difference between the highest and the second highest PFC emissions (in thousand metric tons of CO2 equivalent) in 2008?
Make the answer very short. 758.4. What is the difference between the highest and the lowest PFC emissions (in thousand metric tons of CO2 equivalent) in 1990?
Provide a succinct answer. 4400.8. What is the difference between the highest and the lowest PFC emissions (in thousand metric tons of CO2 equivalent) of 2000?
Your answer should be very brief. 1652.4. What is the difference between the highest and the lowest PFC emissions (in thousand metric tons of CO2 equivalent) in 2005?
Your answer should be very brief. 1743.7. What is the difference between the highest and the lowest PFC emissions (in thousand metric tons of CO2 equivalent) in 2008?
Provide a succinct answer. 1856.4. 